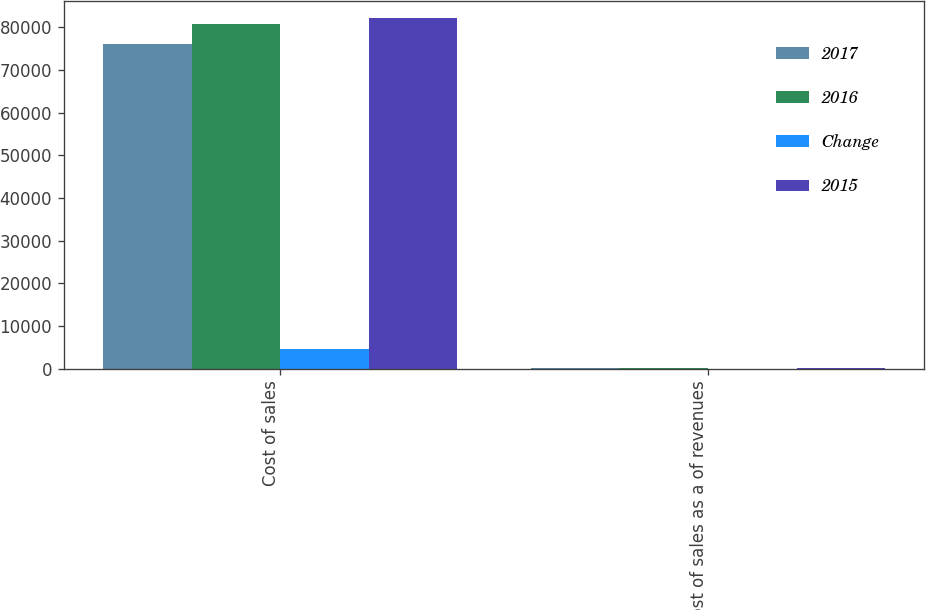Convert chart to OTSL. <chart><loc_0><loc_0><loc_500><loc_500><stacked_bar_chart><ecel><fcel>Cost of sales<fcel>Cost of sales as a of revenues<nl><fcel>2017<fcel>76066<fcel>81.4<nl><fcel>2016<fcel>80790<fcel>85.4<nl><fcel>Change<fcel>4724<fcel>4<nl><fcel>2015<fcel>82088<fcel>85.4<nl></chart> 